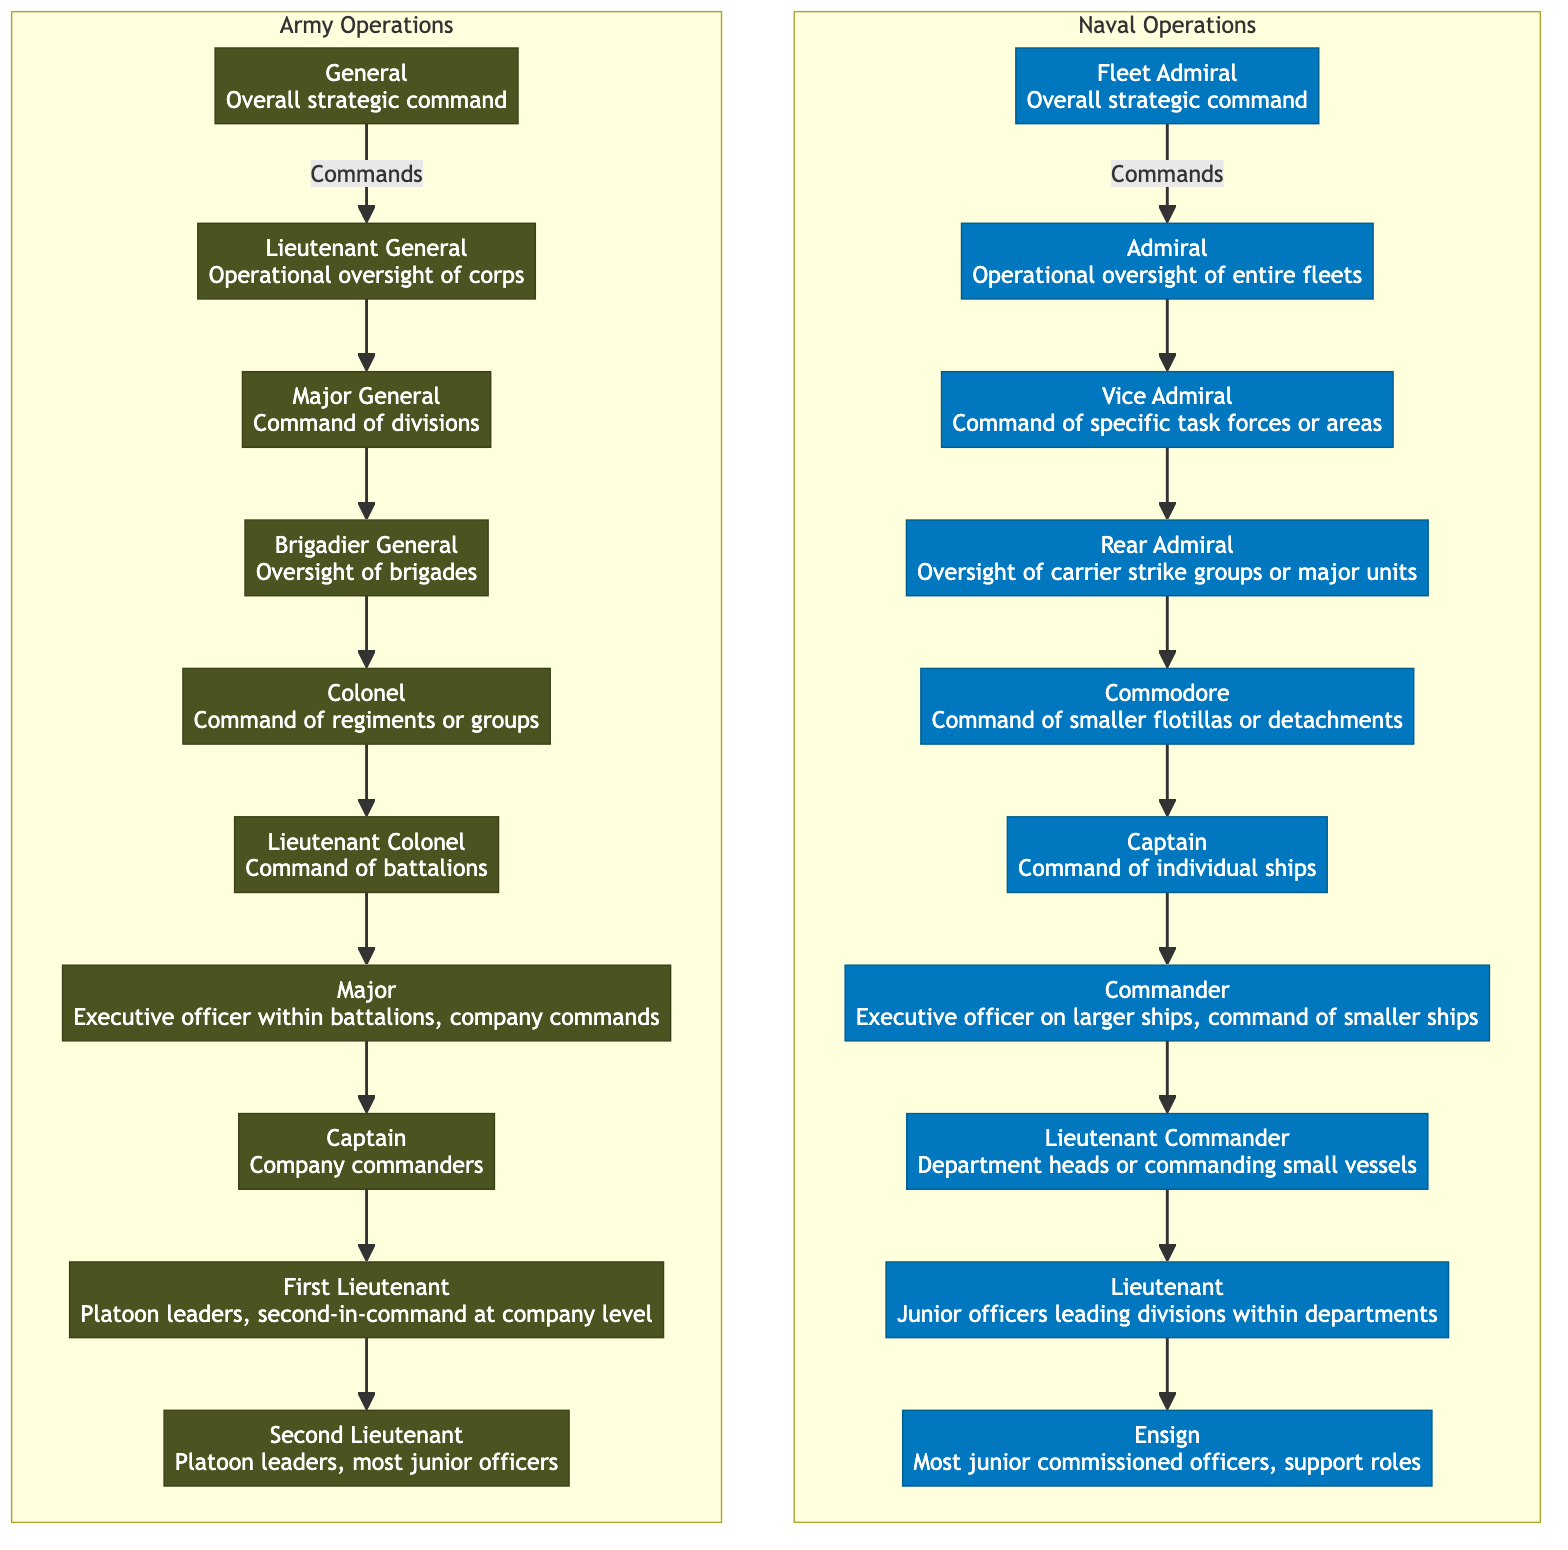What is the role of the Fleet Admiral? The Fleet Admiral has the role of "Overall strategic command" as indicated in the diagram.
Answer: Overall strategic command How many subordinates does the Admiral have? The Admiral directly commands one subordinate, which is the Vice Admiral, as shown in the hierarchy.
Answer: 1 What is the highest rank in Army Operations? The diagram indicates that the highest rank in Army Operations is "General."
Answer: General Which officer commands a regiment or group in Army Operations? The diagram shows that the Colonel is responsible for commanding a regiment or group.
Answer: Colonel What's the relationship between the Captain and the First Lieutenant in Army Operations? The diagram illustrates that the Captain oversees the First Lieutenant, who leads platoon leaders at the company level.
Answer: Captain oversees What is the lowest rank in Naval Operations? The lowest rank listed in the Naval Operations hierarchy is the Ensign, as represented in the diagram.
Answer: Ensign How many levels of command are there in Naval Operations? By counting the ranks from Fleet Admiral down to Ensign, there are six levels of command in Naval Operations.
Answer: 6 What is the role of a Major in Army Operations? The Major serves as the Executive officer within battalions and commands company operations.
Answer: Executive officer within battalions, company commands How does the number of ranks compare between Naval and Army Operations? The Naval Operations hierarchy consists of 10 ranks, while the Army Operations hierarchy consists of 9 ranks, indicating one more rank in Naval Operations.
Answer: Naval has 10, Army has 9 